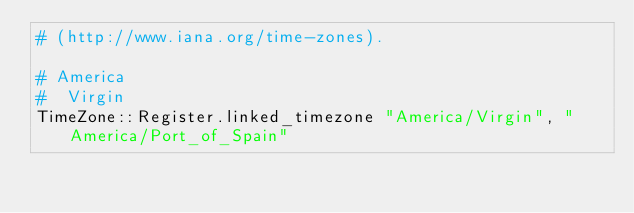Convert code to text. <code><loc_0><loc_0><loc_500><loc_500><_Crystal_># (http://www.iana.org/time-zones).

# America
#  Virgin
TimeZone::Register.linked_timezone "America/Virgin", "America/Port_of_Spain"
</code> 